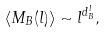<formula> <loc_0><loc_0><loc_500><loc_500>\langle M _ { B } ( { l } ) \rangle \sim { l } ^ { d _ { B } ^ { l } } ,</formula> 